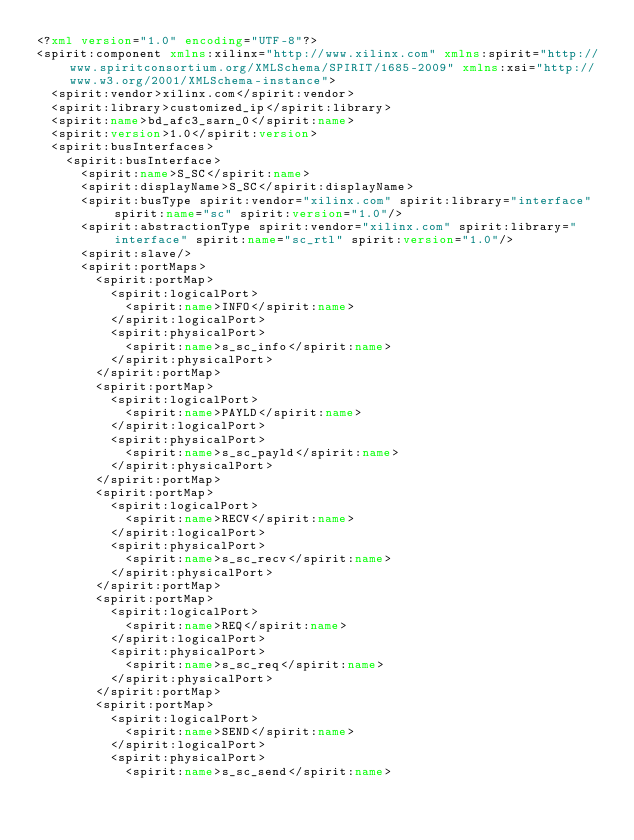<code> <loc_0><loc_0><loc_500><loc_500><_XML_><?xml version="1.0" encoding="UTF-8"?>
<spirit:component xmlns:xilinx="http://www.xilinx.com" xmlns:spirit="http://www.spiritconsortium.org/XMLSchema/SPIRIT/1685-2009" xmlns:xsi="http://www.w3.org/2001/XMLSchema-instance">
  <spirit:vendor>xilinx.com</spirit:vendor>
  <spirit:library>customized_ip</spirit:library>
  <spirit:name>bd_afc3_sarn_0</spirit:name>
  <spirit:version>1.0</spirit:version>
  <spirit:busInterfaces>
    <spirit:busInterface>
      <spirit:name>S_SC</spirit:name>
      <spirit:displayName>S_SC</spirit:displayName>
      <spirit:busType spirit:vendor="xilinx.com" spirit:library="interface" spirit:name="sc" spirit:version="1.0"/>
      <spirit:abstractionType spirit:vendor="xilinx.com" spirit:library="interface" spirit:name="sc_rtl" spirit:version="1.0"/>
      <spirit:slave/>
      <spirit:portMaps>
        <spirit:portMap>
          <spirit:logicalPort>
            <spirit:name>INFO</spirit:name>
          </spirit:logicalPort>
          <spirit:physicalPort>
            <spirit:name>s_sc_info</spirit:name>
          </spirit:physicalPort>
        </spirit:portMap>
        <spirit:portMap>
          <spirit:logicalPort>
            <spirit:name>PAYLD</spirit:name>
          </spirit:logicalPort>
          <spirit:physicalPort>
            <spirit:name>s_sc_payld</spirit:name>
          </spirit:physicalPort>
        </spirit:portMap>
        <spirit:portMap>
          <spirit:logicalPort>
            <spirit:name>RECV</spirit:name>
          </spirit:logicalPort>
          <spirit:physicalPort>
            <spirit:name>s_sc_recv</spirit:name>
          </spirit:physicalPort>
        </spirit:portMap>
        <spirit:portMap>
          <spirit:logicalPort>
            <spirit:name>REQ</spirit:name>
          </spirit:logicalPort>
          <spirit:physicalPort>
            <spirit:name>s_sc_req</spirit:name>
          </spirit:physicalPort>
        </spirit:portMap>
        <spirit:portMap>
          <spirit:logicalPort>
            <spirit:name>SEND</spirit:name>
          </spirit:logicalPort>
          <spirit:physicalPort>
            <spirit:name>s_sc_send</spirit:name></code> 